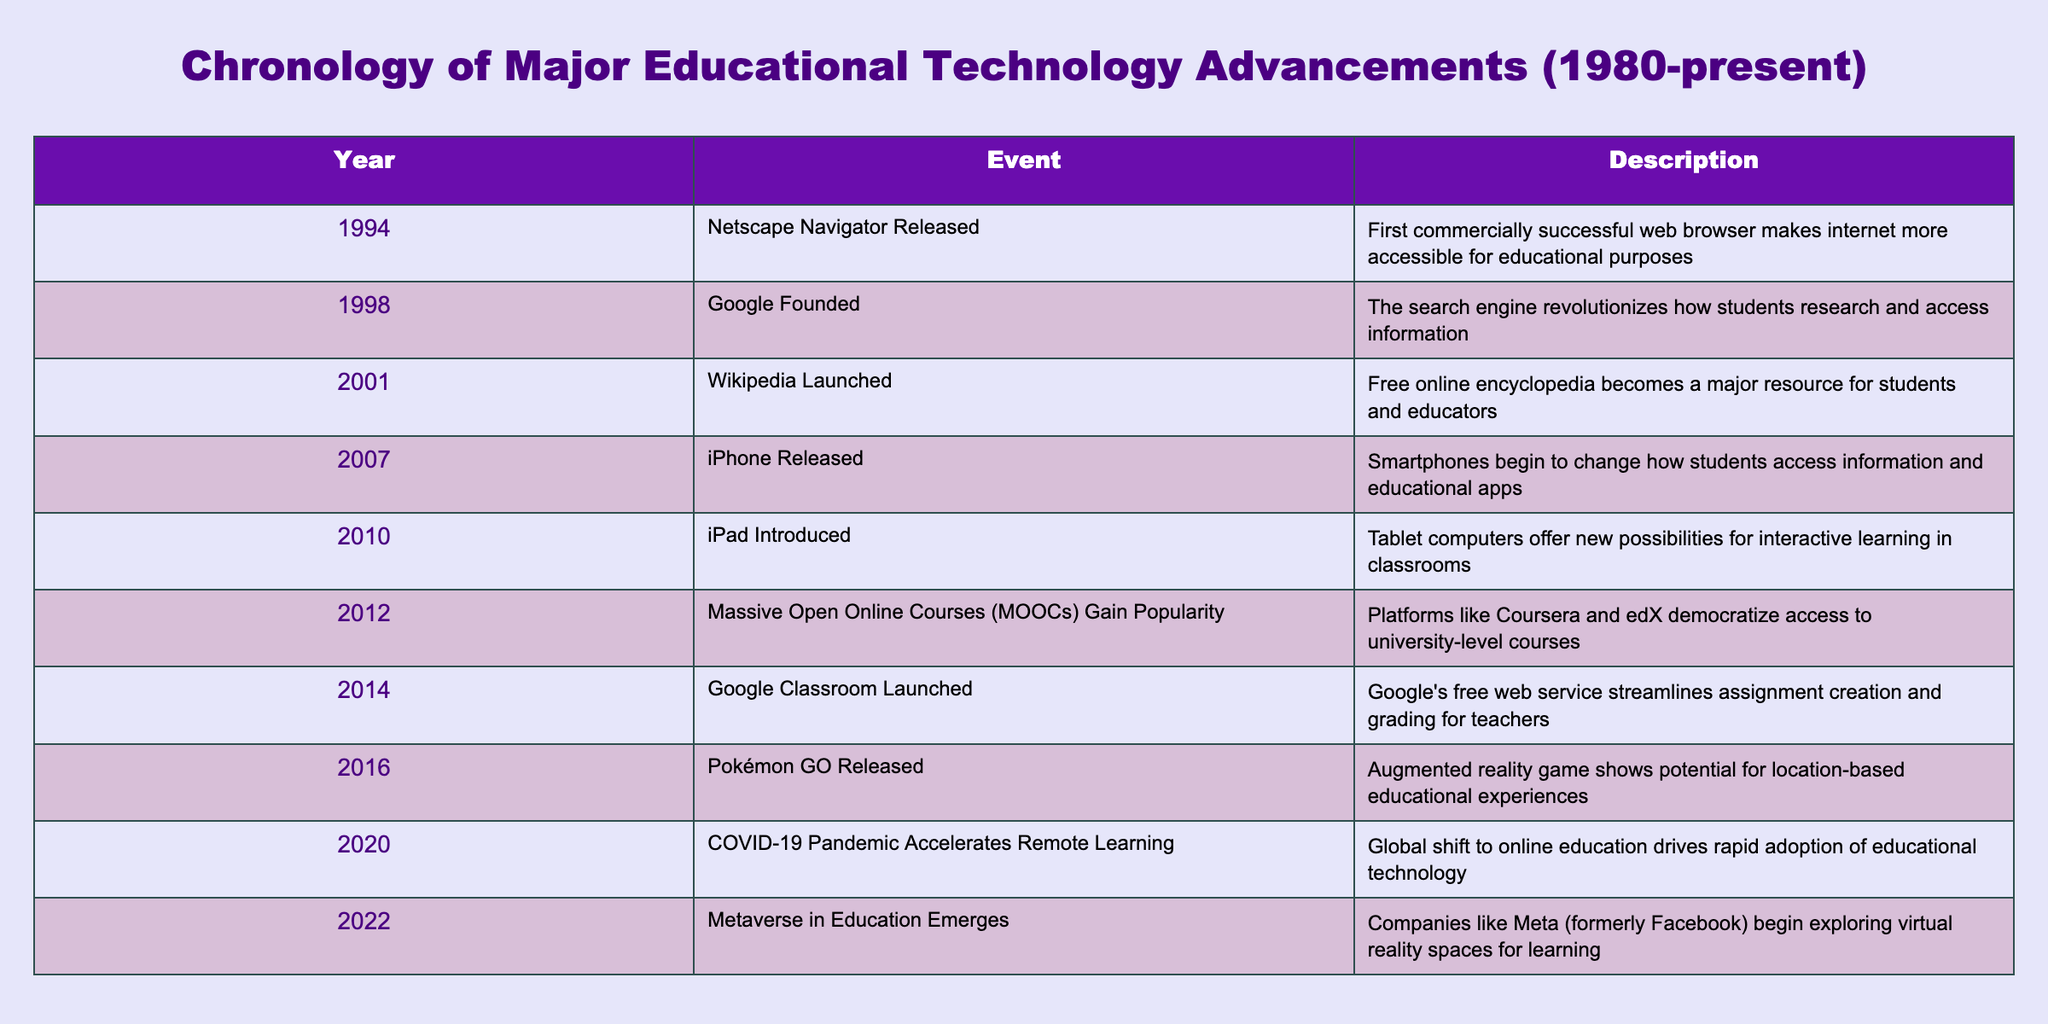What year was Wikipedia launched? The table provides a row that specifically lists Wikipedia's launch year as 2001.
Answer: 2001 Which educational technology advancement happened first, Google or the iPhone? According to the table, Google was founded in 1998 while the iPhone was released in 2007. Therefore, Google occurred first.
Answer: Google Is it true that the COVID-19 pandemic accelerated remote learning? The table mentions that the COVID-19 pandemic in 2020 accelerated remote learning, confirming this statement as true.
Answer: Yes How many years passed between the release of iPhones and the introduction of iPads? The iPhone was released in 2007 and the iPad was introduced in 2010. The difference is 2010 - 2007 = 3 years.
Answer: 3 years What significant event in educational technology occurred in 2014? The table lists Google Classroom's launch as the significant event in educational technology for the year 2014.
Answer: Google Classroom Launched In which year did the emergence of the Metaverse in education occur relative to the availability of MOOCs? The table shows that the Metaverse in education emerged in 2022, several years after MOOCs gained popularity starting in 2012. Thus, the Metaverse appeared 10 years after MOOCs.
Answer: 10 years What was the overall trend in educational technology advancements from 1980 to 2022? By examining the years listed in the table, we see that advancements have accelerated significantly, particularly during events like the pandemic in 2020, which indicates a trend towards increasing reliance on technology in education over time.
Answer: Increasing reliance on technology Was any major educational technology released in the 1990s? The table provides two events in the 1990s; Netscape Navigator was released in 1994 and Google was founded in 1998, confirming the release of major educational technology in that decade.
Answer: Yes Can you identify a technology developed after 2010 that supports interactive learning? The table indicates that the iPad, introduced in 2010, provides new possibilities for interactive learning, fulfilling the criteria since its introduction is after 2010.
Answer: iPad 